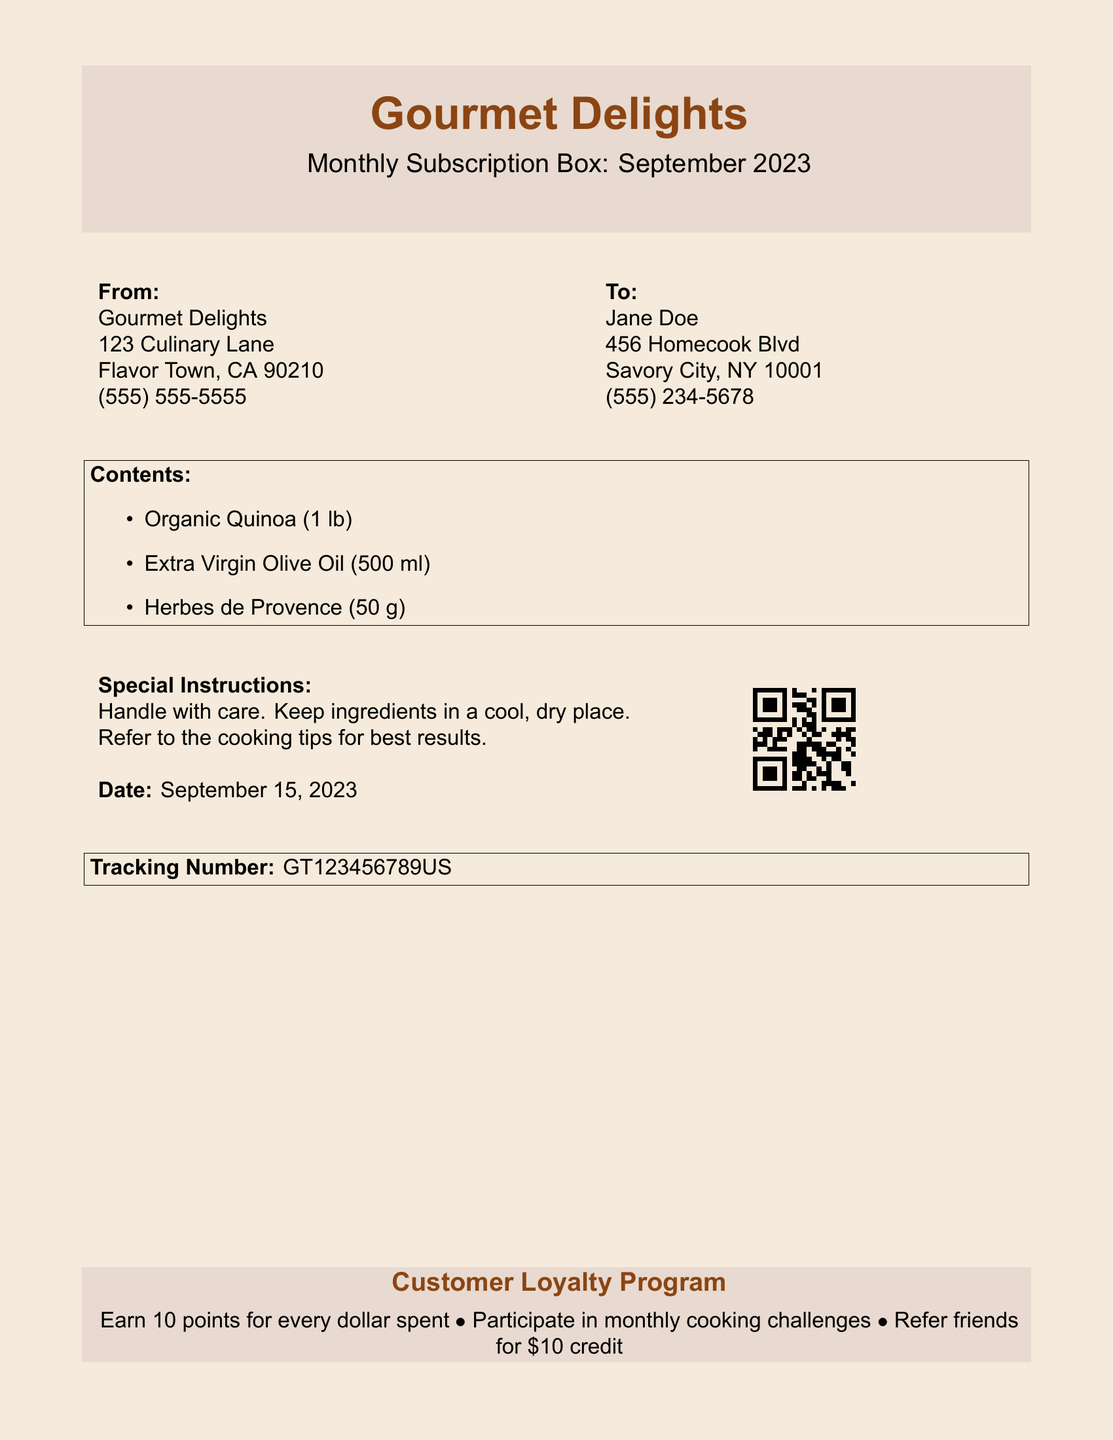What is the name of the company? The company name is prominently displayed at the top of the document as "Gourmet Delights."
Answer: Gourmet Delights What is the date of shipment? The date is noted in the "Date" section of the shipping label as "September 15, 2023."
Answer: September 15, 2023 Who is the recipient of this shipment? The recipient name is listed in the "To" section, indicating who the box is addressed to.
Answer: Jane Doe What is the contents of the subscription box? The contents are listed under the "Contents" section, summarizing the items included.
Answer: Organic Quinoa, Extra Virgin Olive Oil, Herbes de Provence What is the tracking number for this shipment? The tracking number is clearly indicated towards the end of the document.
Answer: GT123456789US What special instructions are provided? Special instructions are summarized in the relevant section of the document, advising on handling and storage.
Answer: Handle with care How many points does a customer earn for every dollar spent? The points earned for each dollar spent are detailed in the loyalty program section.
Answer: 10 points What is one way to earn credits in the customer loyalty program? The loyalty program section lists several activities for earning credits; one is mentioned.
Answer: Refer friends What quantity of Extra Virgin Olive Oil is included? The quantity of Extra Virgin Olive Oil is specified in the "Contents" section as part of the items listed.
Answer: 500 ml 